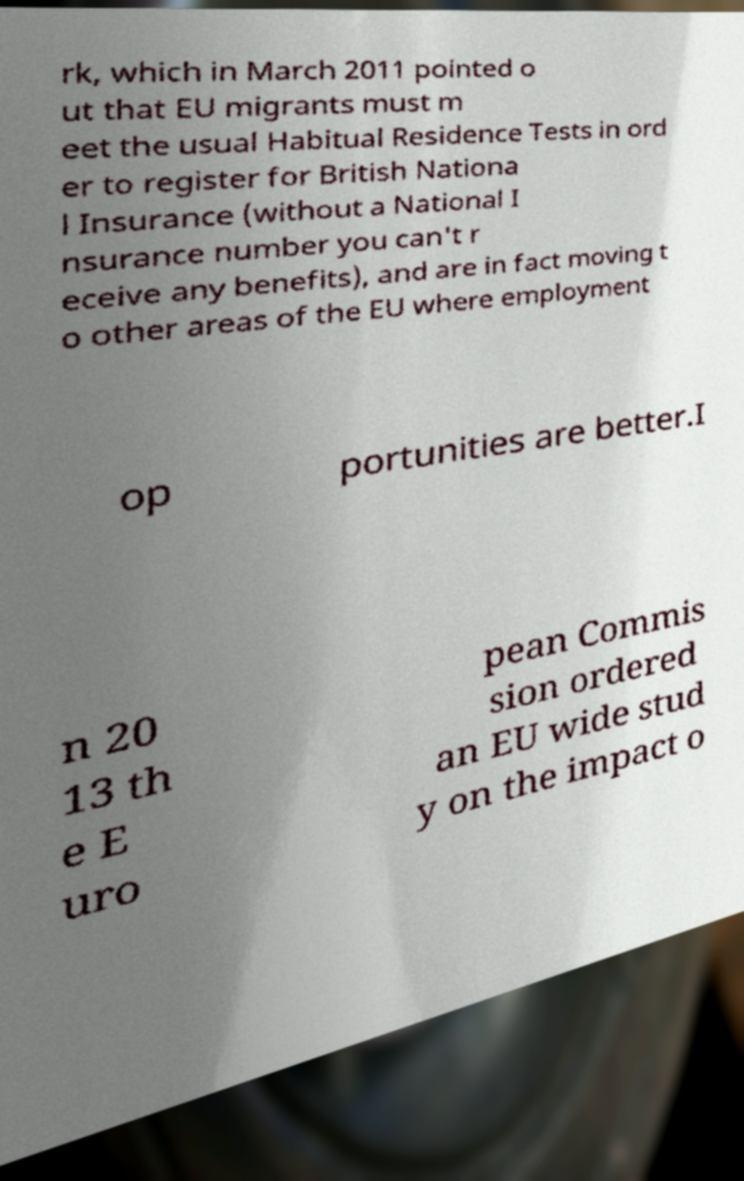I need the written content from this picture converted into text. Can you do that? rk, which in March 2011 pointed o ut that EU migrants must m eet the usual Habitual Residence Tests in ord er to register for British Nationa l Insurance (without a National I nsurance number you can't r eceive any benefits), and are in fact moving t o other areas of the EU where employment op portunities are better.I n 20 13 th e E uro pean Commis sion ordered an EU wide stud y on the impact o 